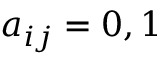Convert formula to latex. <formula><loc_0><loc_0><loc_500><loc_500>a _ { i j } = 0 , 1</formula> 